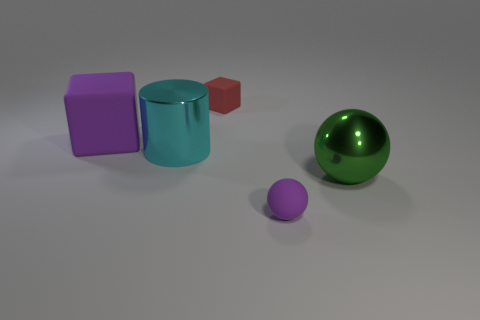What is the color of the cube that is right of the cylinder that is behind the purple matte object on the right side of the cylinder?
Offer a terse response. Red. There is a tiny purple object that is the same shape as the green object; what is its material?
Provide a short and direct response. Rubber. What is the color of the large ball?
Make the answer very short. Green. Do the small rubber cube and the tiny matte sphere have the same color?
Offer a terse response. No. What number of matte things are either small brown cylinders or big purple cubes?
Offer a terse response. 1. Are there any small purple rubber things that are in front of the tiny matte object that is behind the block in front of the tiny rubber block?
Provide a succinct answer. Yes. There is another block that is the same material as the red block; what is its size?
Ensure brevity in your answer.  Large. Are there any blocks on the right side of the big green metal ball?
Your answer should be very brief. No. There is a large thing that is behind the shiny cylinder; are there any big cylinders on the left side of it?
Provide a succinct answer. No. Is the size of the metallic object that is on the left side of the purple sphere the same as the rubber object behind the big purple rubber cube?
Give a very brief answer. No. 